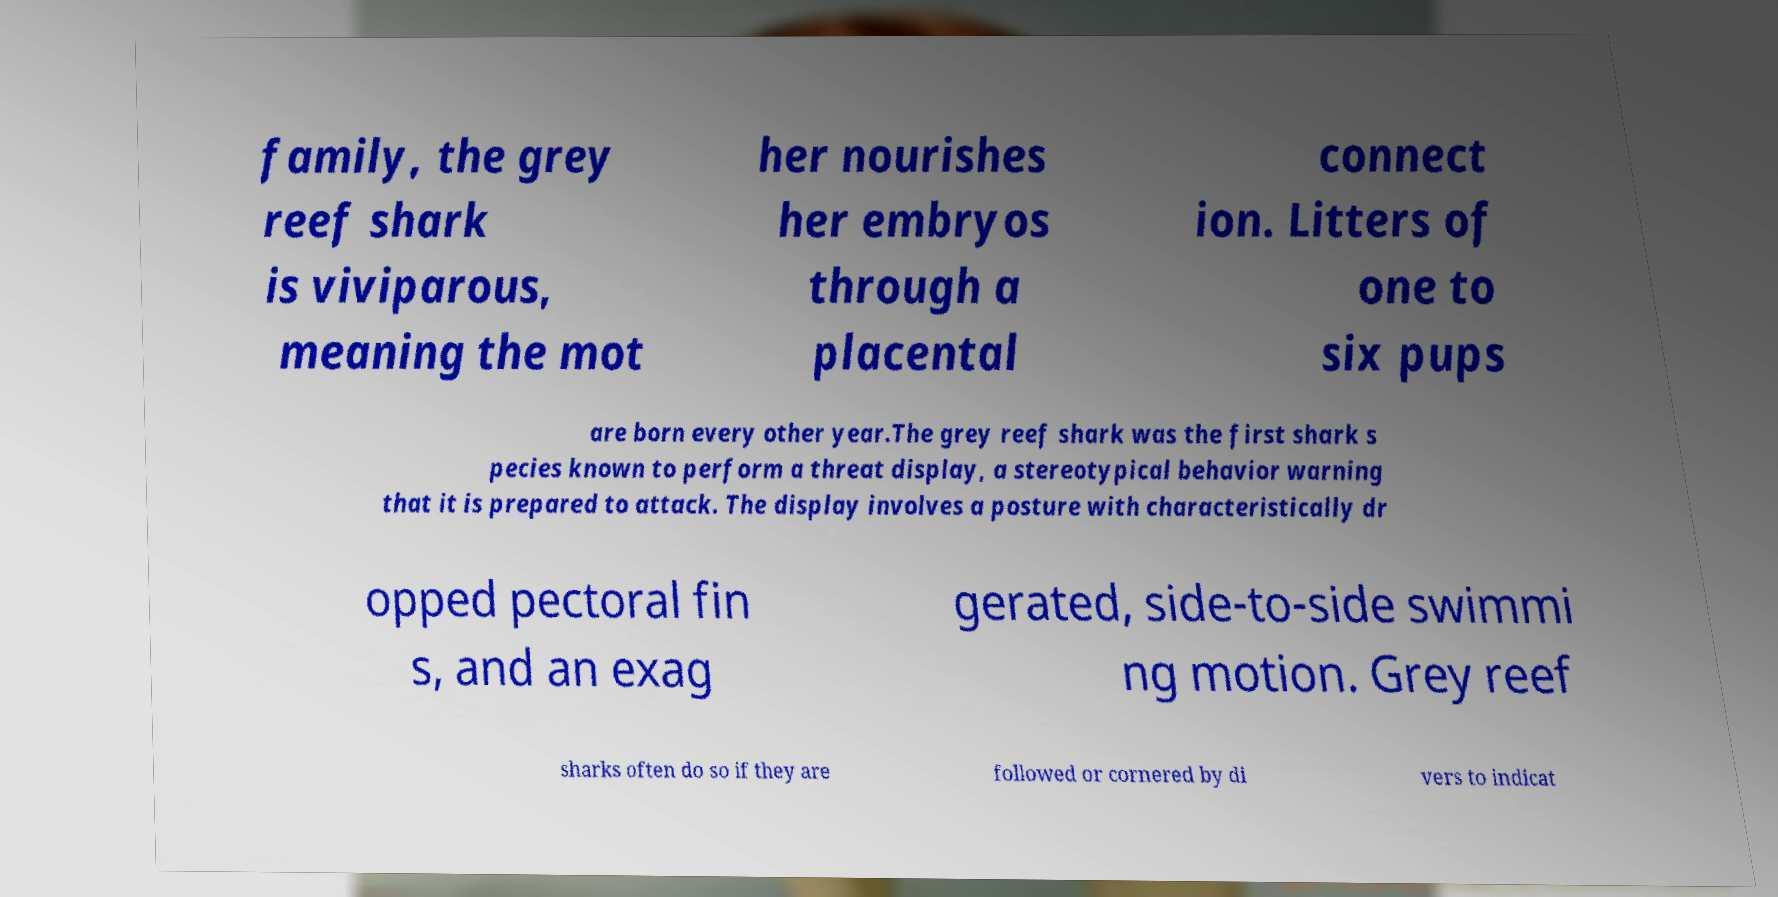I need the written content from this picture converted into text. Can you do that? family, the grey reef shark is viviparous, meaning the mot her nourishes her embryos through a placental connect ion. Litters of one to six pups are born every other year.The grey reef shark was the first shark s pecies known to perform a threat display, a stereotypical behavior warning that it is prepared to attack. The display involves a posture with characteristically dr opped pectoral fin s, and an exag gerated, side-to-side swimmi ng motion. Grey reef sharks often do so if they are followed or cornered by di vers to indicat 